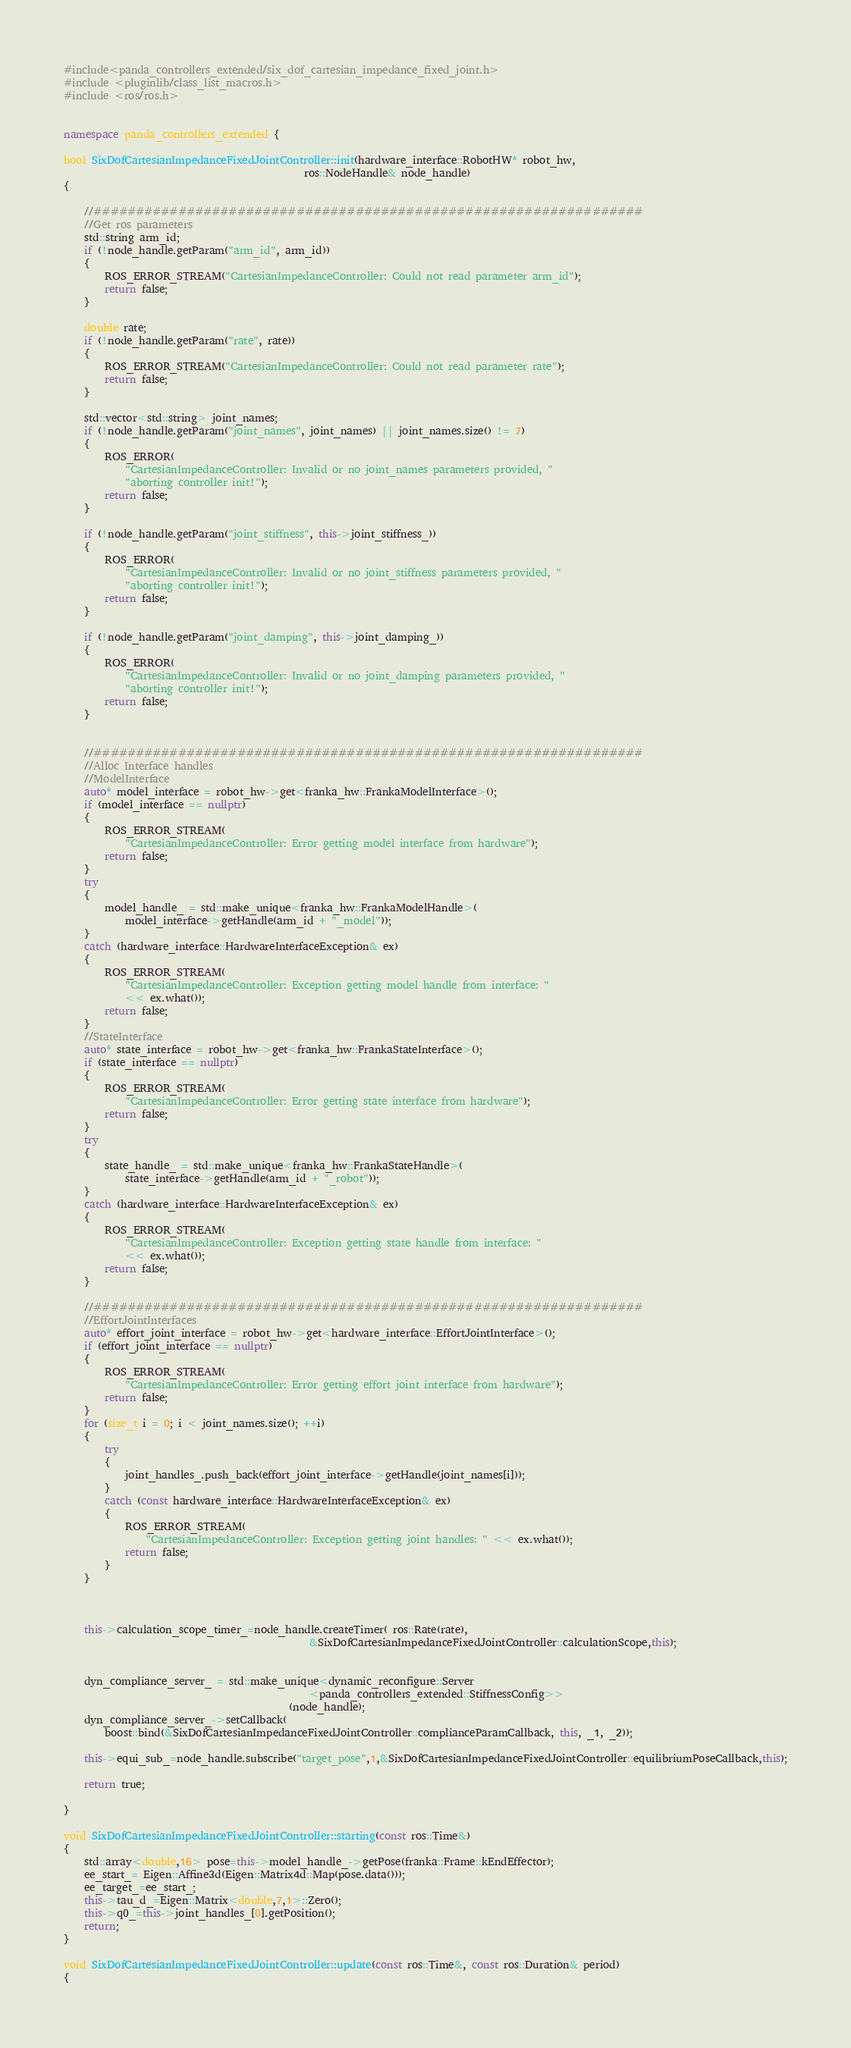<code> <loc_0><loc_0><loc_500><loc_500><_C++_>#include<panda_controllers_extended/six_dof_cartesian_impedance_fixed_joint.h>
#include <pluginlib/class_list_macros.h>
#include <ros/ros.h>


namespace panda_controllers_extended {

bool SixDofCartesianImpedanceFixedJointController::init(hardware_interface::RobotHW* robot_hw,
                                               ros::NodeHandle& node_handle) 
{

    //#################################################################
    //Get ros parameters
    std::string arm_id;
    if (!node_handle.getParam("arm_id", arm_id)) 
    {
        ROS_ERROR_STREAM("CartesianImpedanceController: Could not read parameter arm_id");
        return false;
    }
  
    double rate;
    if (!node_handle.getParam("rate", rate)) 
    {
        ROS_ERROR_STREAM("CartesianImpedanceController: Could not read parameter rate");
        return false;
    }

    std::vector<std::string> joint_names;
    if (!node_handle.getParam("joint_names", joint_names) || joint_names.size() != 7) 
    {
        ROS_ERROR(
            "CartesianImpedanceController: Invalid or no joint_names parameters provided, "
            "aborting controller init!");
        return false;
    }

    if (!node_handle.getParam("joint_stiffness", this->joint_stiffness_))
    {
        ROS_ERROR(
            "CartesianImpedanceController: Invalid or no joint_stiffness parameters provided, "
            "aborting controller init!");
        return false;
    }

    if (!node_handle.getParam("joint_damping", this->joint_damping_))
    {
        ROS_ERROR(
            "CartesianImpedanceController: Invalid or no joint_damping parameters provided, "
            "aborting controller init!");
        return false;
    }


    //#################################################################
    //Alloc Interface handles
    //ModelInterface
    auto* model_interface = robot_hw->get<franka_hw::FrankaModelInterface>();
    if (model_interface == nullptr) 
    {
        ROS_ERROR_STREAM(
            "CartesianImpedanceController: Error getting model interface from hardware");
        return false;
    }
    try 
    {
        model_handle_ = std::make_unique<franka_hw::FrankaModelHandle>(
            model_interface->getHandle(arm_id + "_model"));
    } 
    catch (hardware_interface::HardwareInterfaceException& ex) 
    {
        ROS_ERROR_STREAM(
            "CartesianImpedanceController: Exception getting model handle from interface: "
            << ex.what());
        return false;
    }
    //StateInterface
    auto* state_interface = robot_hw->get<franka_hw::FrankaStateInterface>();
    if (state_interface == nullptr) 
    {
        ROS_ERROR_STREAM(
            "CartesianImpedanceController: Error getting state interface from hardware");
        return false;
    }
    try 
    {
        state_handle_ = std::make_unique<franka_hw::FrankaStateHandle>(
            state_interface->getHandle(arm_id + "_robot"));
    } 
    catch (hardware_interface::HardwareInterfaceException& ex) 
    {
        ROS_ERROR_STREAM(
            "CartesianImpedanceController: Exception getting state handle from interface: "
            << ex.what());
        return false;
    }

    //#################################################################
    //EffortJointInterfaces
    auto* effort_joint_interface = robot_hw->get<hardware_interface::EffortJointInterface>();
    if (effort_joint_interface == nullptr) 
    {
        ROS_ERROR_STREAM(
            "CartesianImpedanceController: Error getting effort joint interface from hardware");
        return false;
    }
    for (size_t i = 0; i < joint_names.size(); ++i) 
    {
        try 
        {
            joint_handles_.push_back(effort_joint_interface->getHandle(joint_names[i]));
        } 
        catch (const hardware_interface::HardwareInterfaceException& ex) 
        {
            ROS_ERROR_STREAM(
                "CartesianImpedanceController: Exception getting joint handles: " << ex.what());
            return false;
        }
    }
   


    this->calculation_scope_timer_=node_handle.createTimer( ros::Rate(rate),
                                                &SixDofCartesianImpedanceFixedJointController::calculationScope,this);


    dyn_compliance_server_ = std::make_unique<dynamic_reconfigure::Server
                                                <panda_controllers_extended::StiffnessConfig>>
                                            (node_handle);
    dyn_compliance_server_->setCallback(
        boost::bind(&SixDofCartesianImpedanceFixedJointController::complianceParamCallback, this, _1, _2));

    this->equi_sub_=node_handle.subscribe("target_pose",1,&SixDofCartesianImpedanceFixedJointController::equilibriumPoseCallback,this);
    
    return true;

}

void SixDofCartesianImpedanceFixedJointController::starting(const ros::Time&)
{
    std::array<double,16> pose=this->model_handle_->getPose(franka::Frame::kEndEffector);
    ee_start_= Eigen::Affine3d(Eigen::Matrix4d::Map(pose.data()));
    ee_target_=ee_start_;
    this->tau_d_=Eigen::Matrix<double,7,1>::Zero();
    this->q0_=this->joint_handles_[0].getPosition();
    return;
}

void SixDofCartesianImpedanceFixedJointController::update(const ros::Time&, const ros::Duration& period)
{</code> 